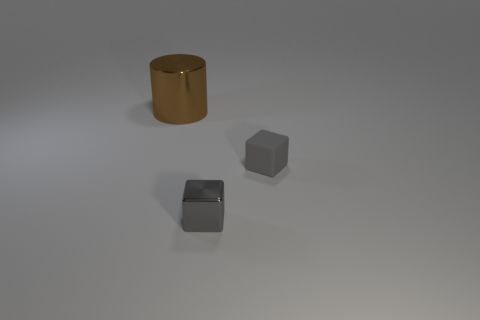Add 1 green metallic cubes. How many objects exist? 4 Subtract all cylinders. How many objects are left? 2 Subtract all small cyan rubber things. Subtract all tiny gray shiny cubes. How many objects are left? 2 Add 2 tiny gray things. How many tiny gray things are left? 4 Add 1 tiny matte blocks. How many tiny matte blocks exist? 2 Subtract 0 brown cubes. How many objects are left? 3 